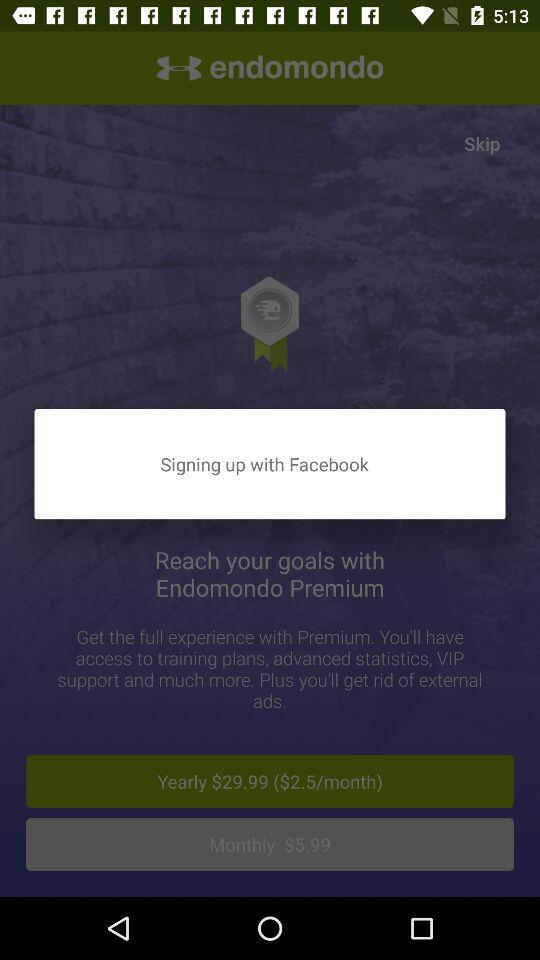How much is the yearly subscription for Endomondo Premium?
Answer the question using a single word or phrase. $29.99 